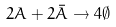<formula> <loc_0><loc_0><loc_500><loc_500>2 A + 2 \bar { A } \to 4 \emptyset</formula> 